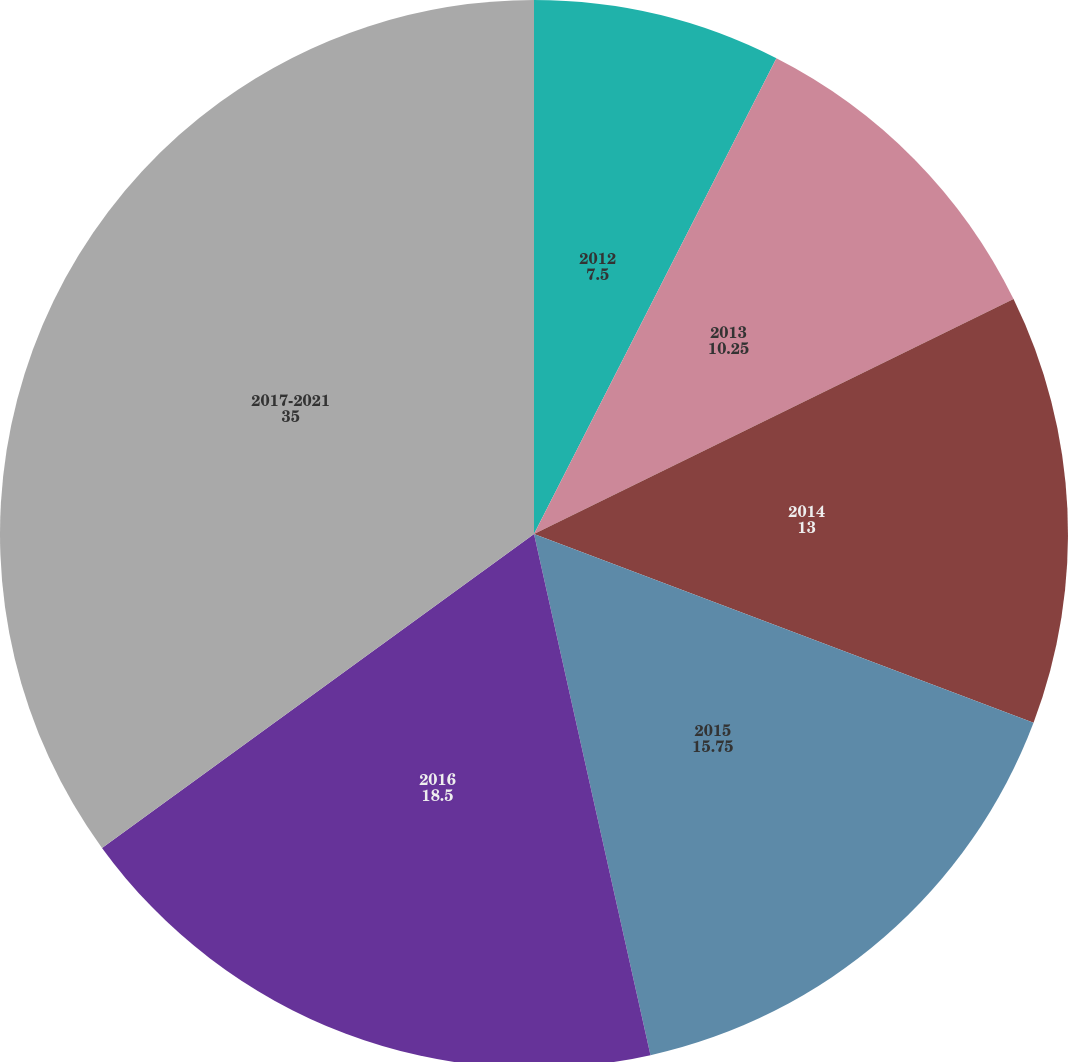Convert chart to OTSL. <chart><loc_0><loc_0><loc_500><loc_500><pie_chart><fcel>2012<fcel>2013<fcel>2014<fcel>2015<fcel>2016<fcel>2017-2021<nl><fcel>7.5%<fcel>10.25%<fcel>13.0%<fcel>15.75%<fcel>18.5%<fcel>35.0%<nl></chart> 